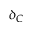Convert formula to latex. <formula><loc_0><loc_0><loc_500><loc_500>\delta _ { C }</formula> 